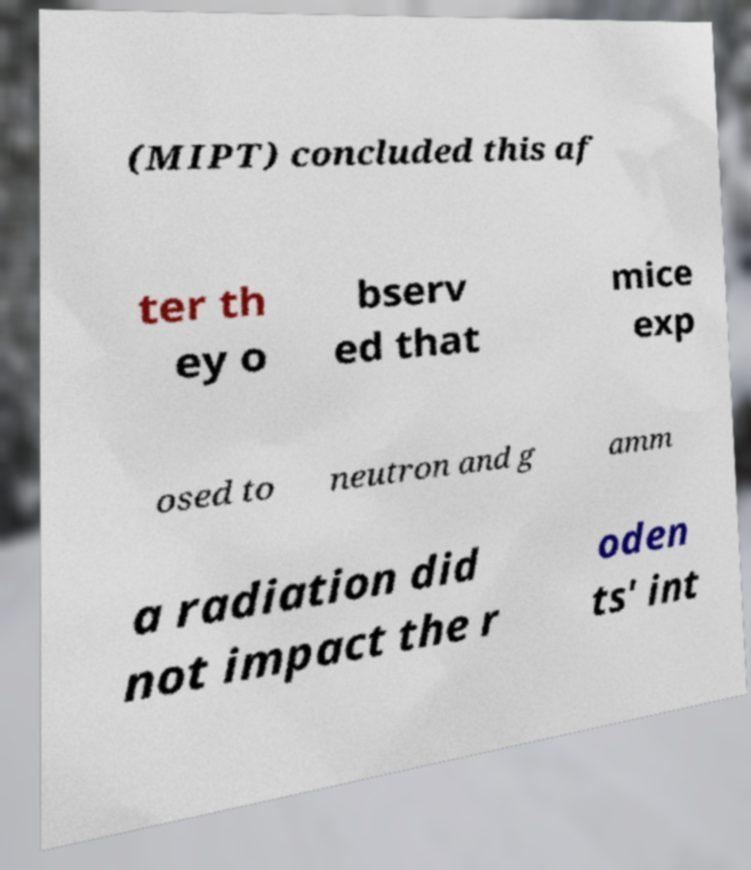What messages or text are displayed in this image? I need them in a readable, typed format. (MIPT) concluded this af ter th ey o bserv ed that mice exp osed to neutron and g amm a radiation did not impact the r oden ts' int 